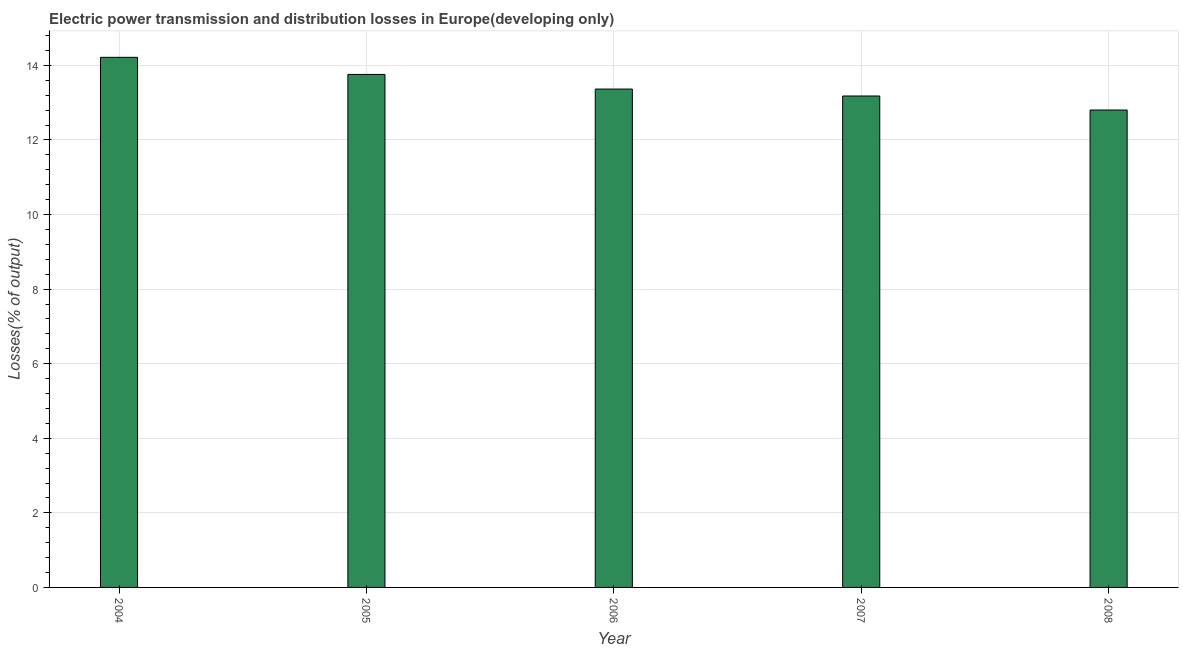Does the graph contain grids?
Your response must be concise. Yes. What is the title of the graph?
Provide a succinct answer. Electric power transmission and distribution losses in Europe(developing only). What is the label or title of the X-axis?
Offer a very short reply. Year. What is the label or title of the Y-axis?
Give a very brief answer. Losses(% of output). What is the electric power transmission and distribution losses in 2006?
Provide a short and direct response. 13.36. Across all years, what is the maximum electric power transmission and distribution losses?
Give a very brief answer. 14.22. Across all years, what is the minimum electric power transmission and distribution losses?
Offer a very short reply. 12.8. In which year was the electric power transmission and distribution losses maximum?
Your answer should be compact. 2004. In which year was the electric power transmission and distribution losses minimum?
Provide a short and direct response. 2008. What is the sum of the electric power transmission and distribution losses?
Provide a short and direct response. 67.32. What is the difference between the electric power transmission and distribution losses in 2006 and 2008?
Provide a succinct answer. 0.56. What is the average electric power transmission and distribution losses per year?
Your response must be concise. 13.46. What is the median electric power transmission and distribution losses?
Your answer should be very brief. 13.36. In how many years, is the electric power transmission and distribution losses greater than 0.8 %?
Offer a very short reply. 5. What is the ratio of the electric power transmission and distribution losses in 2006 to that in 2008?
Keep it short and to the point. 1.04. Is the electric power transmission and distribution losses in 2004 less than that in 2005?
Offer a very short reply. No. Is the difference between the electric power transmission and distribution losses in 2005 and 2007 greater than the difference between any two years?
Your answer should be compact. No. What is the difference between the highest and the second highest electric power transmission and distribution losses?
Provide a succinct answer. 0.46. Is the sum of the electric power transmission and distribution losses in 2007 and 2008 greater than the maximum electric power transmission and distribution losses across all years?
Your answer should be compact. Yes. What is the difference between the highest and the lowest electric power transmission and distribution losses?
Provide a short and direct response. 1.41. How many bars are there?
Make the answer very short. 5. Are all the bars in the graph horizontal?
Provide a succinct answer. No. How many years are there in the graph?
Your response must be concise. 5. What is the difference between two consecutive major ticks on the Y-axis?
Your answer should be very brief. 2. Are the values on the major ticks of Y-axis written in scientific E-notation?
Ensure brevity in your answer.  No. What is the Losses(% of output) in 2004?
Your answer should be very brief. 14.22. What is the Losses(% of output) of 2005?
Provide a short and direct response. 13.76. What is the Losses(% of output) in 2006?
Offer a very short reply. 13.36. What is the Losses(% of output) of 2007?
Make the answer very short. 13.18. What is the Losses(% of output) of 2008?
Provide a succinct answer. 12.8. What is the difference between the Losses(% of output) in 2004 and 2005?
Ensure brevity in your answer.  0.46. What is the difference between the Losses(% of output) in 2004 and 2006?
Offer a terse response. 0.85. What is the difference between the Losses(% of output) in 2004 and 2007?
Offer a very short reply. 1.04. What is the difference between the Losses(% of output) in 2004 and 2008?
Give a very brief answer. 1.41. What is the difference between the Losses(% of output) in 2005 and 2006?
Your answer should be very brief. 0.39. What is the difference between the Losses(% of output) in 2005 and 2007?
Keep it short and to the point. 0.58. What is the difference between the Losses(% of output) in 2005 and 2008?
Ensure brevity in your answer.  0.95. What is the difference between the Losses(% of output) in 2006 and 2007?
Keep it short and to the point. 0.19. What is the difference between the Losses(% of output) in 2006 and 2008?
Your response must be concise. 0.56. What is the difference between the Losses(% of output) in 2007 and 2008?
Provide a succinct answer. 0.38. What is the ratio of the Losses(% of output) in 2004 to that in 2005?
Your answer should be very brief. 1.03. What is the ratio of the Losses(% of output) in 2004 to that in 2006?
Keep it short and to the point. 1.06. What is the ratio of the Losses(% of output) in 2004 to that in 2007?
Provide a succinct answer. 1.08. What is the ratio of the Losses(% of output) in 2004 to that in 2008?
Make the answer very short. 1.11. What is the ratio of the Losses(% of output) in 2005 to that in 2006?
Your answer should be compact. 1.03. What is the ratio of the Losses(% of output) in 2005 to that in 2007?
Your answer should be compact. 1.04. What is the ratio of the Losses(% of output) in 2005 to that in 2008?
Give a very brief answer. 1.07. What is the ratio of the Losses(% of output) in 2006 to that in 2008?
Offer a terse response. 1.04. What is the ratio of the Losses(% of output) in 2007 to that in 2008?
Your answer should be compact. 1.03. 